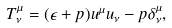Convert formula to latex. <formula><loc_0><loc_0><loc_500><loc_500>T ^ { \mu } _ { \nu } = ( \epsilon + p ) u ^ { \mu } u _ { \nu } - p \delta ^ { \mu } _ { \nu } ,</formula> 